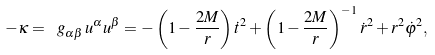Convert formula to latex. <formula><loc_0><loc_0><loc_500><loc_500>- \kappa = \ g _ { \alpha \beta } \, u ^ { \alpha } u ^ { \beta } = - \left ( 1 - \frac { 2 M } { r } \right ) \dot { t } ^ { 2 } + \left ( 1 - \frac { 2 M } { r } \right ) ^ { - 1 } \dot { r } ^ { 2 } + r ^ { 2 } \dot { \varphi } ^ { 2 } ,</formula> 